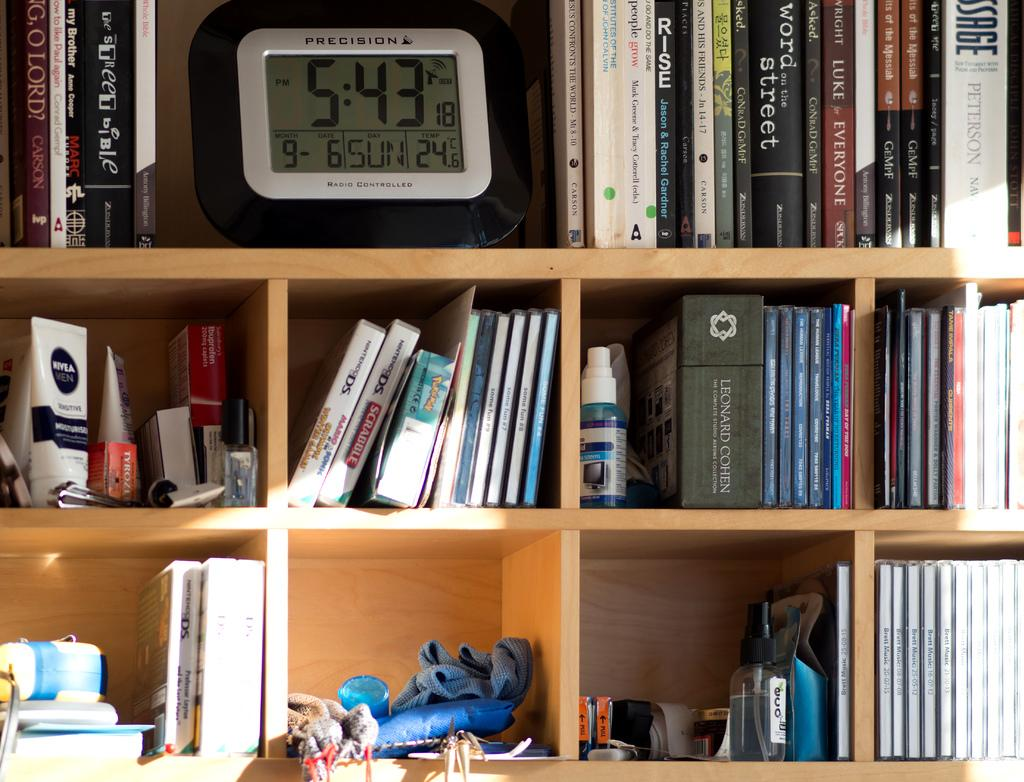<image>
Give a short and clear explanation of the subsequent image. a bookshelf with a precision digital clock on it 